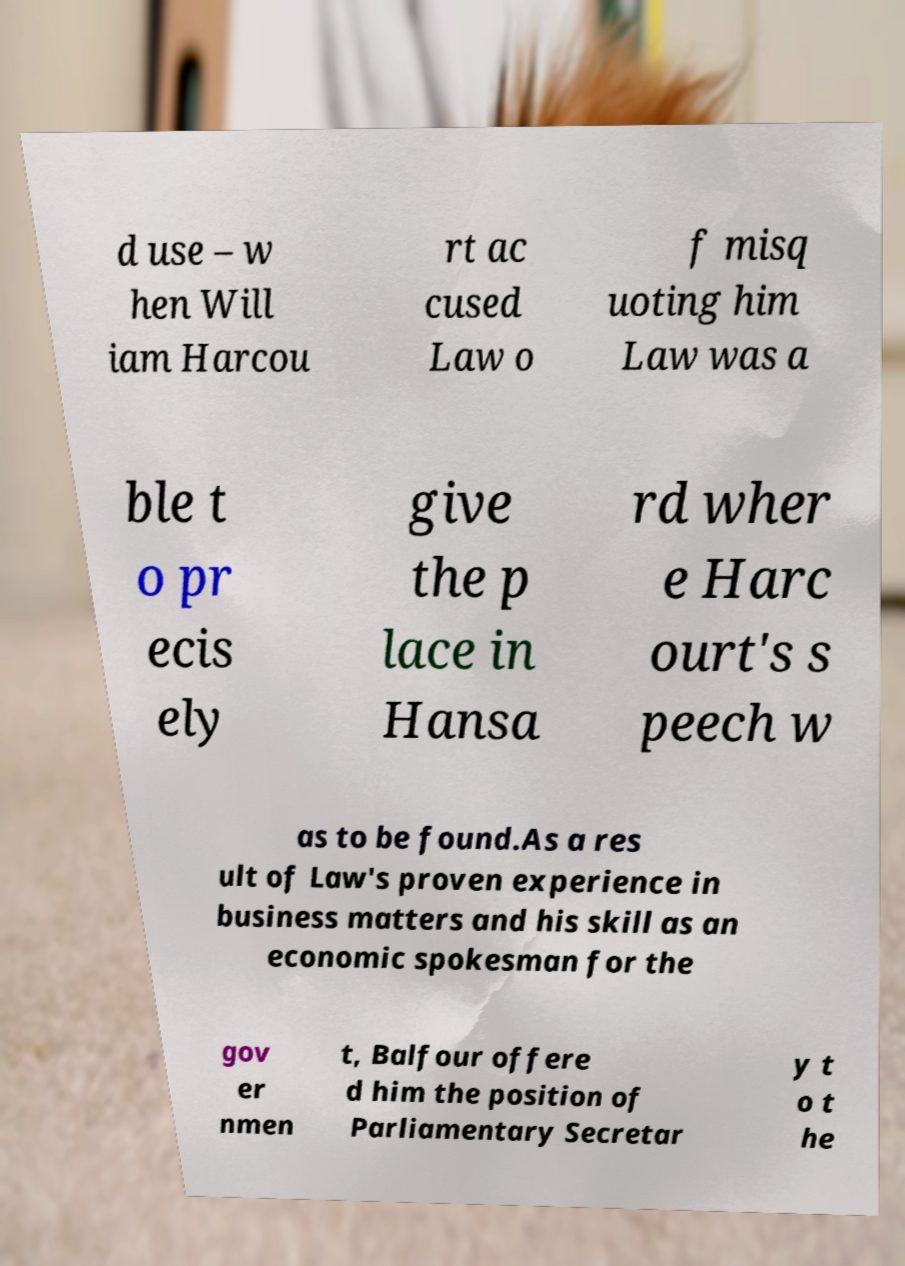Can you accurately transcribe the text from the provided image for me? d use – w hen Will iam Harcou rt ac cused Law o f misq uoting him Law was a ble t o pr ecis ely give the p lace in Hansa rd wher e Harc ourt's s peech w as to be found.As a res ult of Law's proven experience in business matters and his skill as an economic spokesman for the gov er nmen t, Balfour offere d him the position of Parliamentary Secretar y t o t he 